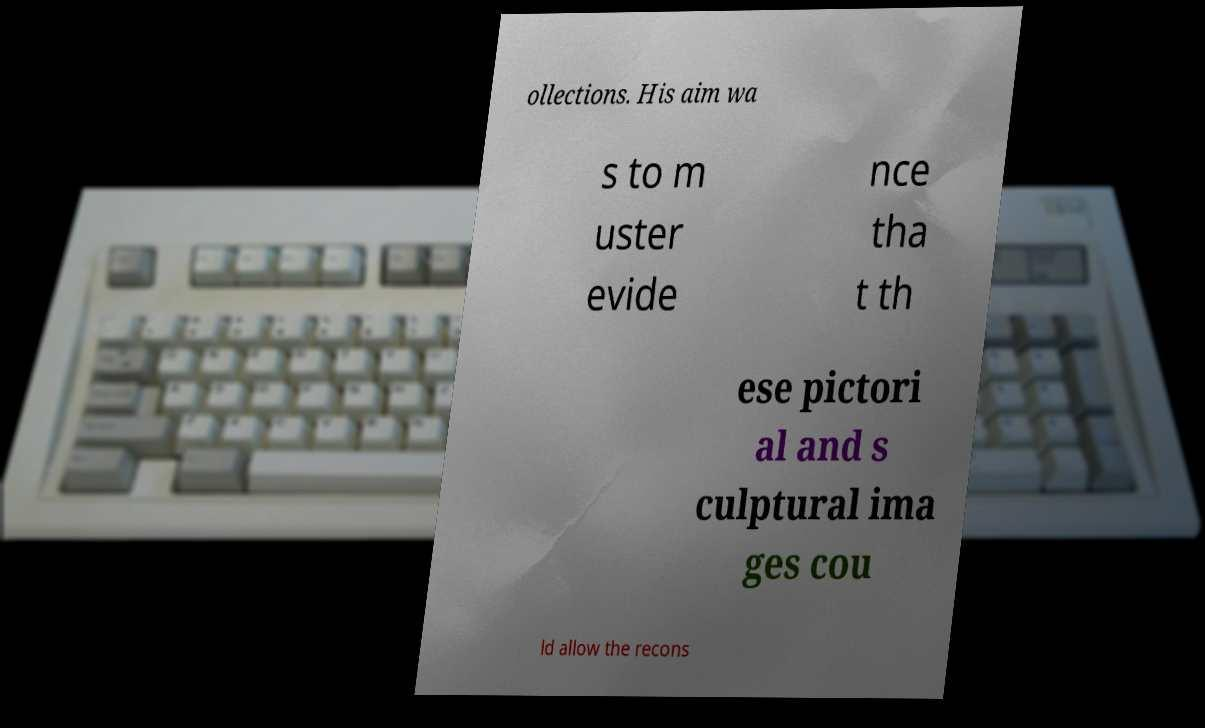Please read and relay the text visible in this image. What does it say? ollections. His aim wa s to m uster evide nce tha t th ese pictori al and s culptural ima ges cou ld allow the recons 